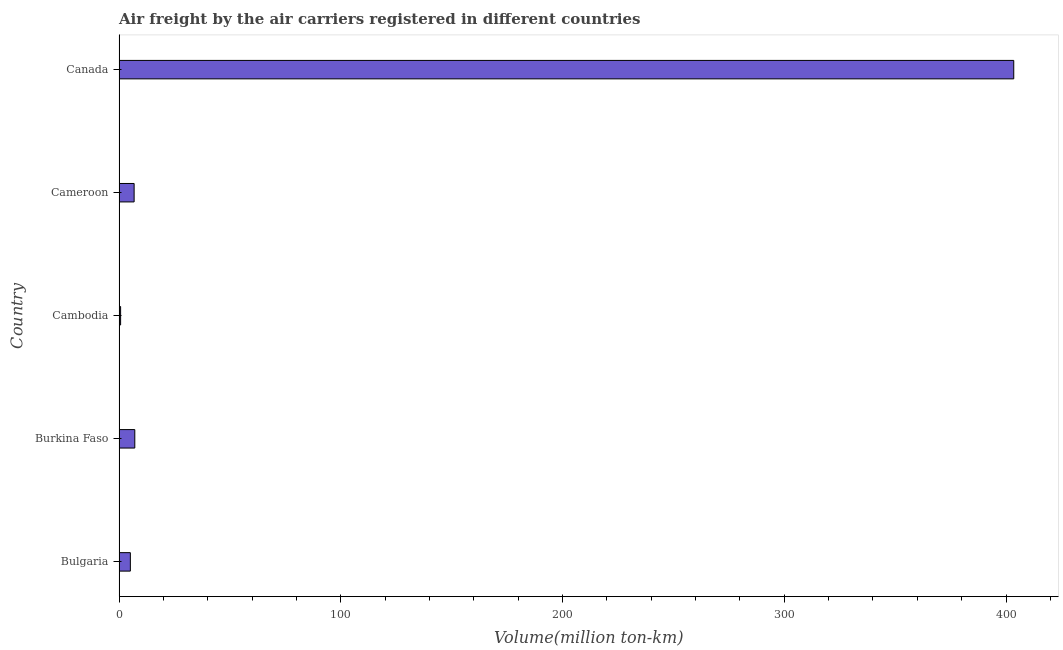Does the graph contain any zero values?
Offer a very short reply. No. Does the graph contain grids?
Your answer should be very brief. No. What is the title of the graph?
Your answer should be compact. Air freight by the air carriers registered in different countries. What is the label or title of the X-axis?
Make the answer very short. Volume(million ton-km). What is the air freight in Bulgaria?
Make the answer very short. 5.1. Across all countries, what is the maximum air freight?
Keep it short and to the point. 403.5. Across all countries, what is the minimum air freight?
Make the answer very short. 0.7. In which country was the air freight minimum?
Make the answer very short. Cambodia. What is the sum of the air freight?
Keep it short and to the point. 423.2. What is the difference between the air freight in Cameroon and Canada?
Give a very brief answer. -396.7. What is the average air freight per country?
Make the answer very short. 84.64. What is the median air freight?
Your answer should be compact. 6.8. What is the ratio of the air freight in Bulgaria to that in Cambodia?
Offer a terse response. 7.29. Is the air freight in Burkina Faso less than that in Cambodia?
Your answer should be compact. No. Is the difference between the air freight in Burkina Faso and Canada greater than the difference between any two countries?
Your response must be concise. No. What is the difference between the highest and the second highest air freight?
Your response must be concise. 396.4. What is the difference between the highest and the lowest air freight?
Keep it short and to the point. 402.8. In how many countries, is the air freight greater than the average air freight taken over all countries?
Offer a very short reply. 1. How many bars are there?
Your answer should be very brief. 5. How many countries are there in the graph?
Provide a succinct answer. 5. What is the difference between two consecutive major ticks on the X-axis?
Give a very brief answer. 100. What is the Volume(million ton-km) in Bulgaria?
Offer a terse response. 5.1. What is the Volume(million ton-km) in Burkina Faso?
Your answer should be compact. 7.1. What is the Volume(million ton-km) of Cambodia?
Your answer should be very brief. 0.7. What is the Volume(million ton-km) of Cameroon?
Your answer should be very brief. 6.8. What is the Volume(million ton-km) of Canada?
Offer a terse response. 403.5. What is the difference between the Volume(million ton-km) in Bulgaria and Cameroon?
Offer a terse response. -1.7. What is the difference between the Volume(million ton-km) in Bulgaria and Canada?
Your response must be concise. -398.4. What is the difference between the Volume(million ton-km) in Burkina Faso and Cameroon?
Your response must be concise. 0.3. What is the difference between the Volume(million ton-km) in Burkina Faso and Canada?
Provide a short and direct response. -396.4. What is the difference between the Volume(million ton-km) in Cambodia and Cameroon?
Keep it short and to the point. -6.1. What is the difference between the Volume(million ton-km) in Cambodia and Canada?
Offer a very short reply. -402.8. What is the difference between the Volume(million ton-km) in Cameroon and Canada?
Keep it short and to the point. -396.7. What is the ratio of the Volume(million ton-km) in Bulgaria to that in Burkina Faso?
Offer a very short reply. 0.72. What is the ratio of the Volume(million ton-km) in Bulgaria to that in Cambodia?
Provide a short and direct response. 7.29. What is the ratio of the Volume(million ton-km) in Bulgaria to that in Cameroon?
Your answer should be very brief. 0.75. What is the ratio of the Volume(million ton-km) in Bulgaria to that in Canada?
Your answer should be very brief. 0.01. What is the ratio of the Volume(million ton-km) in Burkina Faso to that in Cambodia?
Give a very brief answer. 10.14. What is the ratio of the Volume(million ton-km) in Burkina Faso to that in Cameroon?
Your response must be concise. 1.04. What is the ratio of the Volume(million ton-km) in Burkina Faso to that in Canada?
Your answer should be very brief. 0.02. What is the ratio of the Volume(million ton-km) in Cambodia to that in Cameroon?
Provide a short and direct response. 0.1. What is the ratio of the Volume(million ton-km) in Cambodia to that in Canada?
Provide a succinct answer. 0. What is the ratio of the Volume(million ton-km) in Cameroon to that in Canada?
Ensure brevity in your answer.  0.02. 